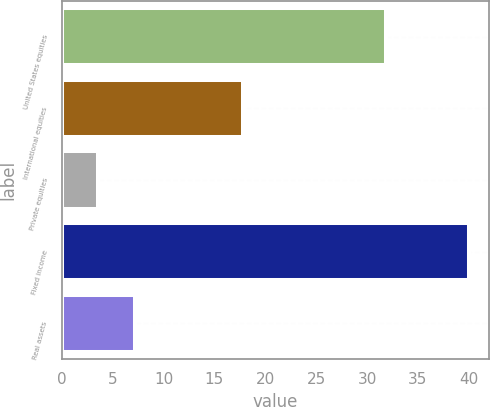Convert chart to OTSL. <chart><loc_0><loc_0><loc_500><loc_500><bar_chart><fcel>United States equities<fcel>International equities<fcel>Private equities<fcel>Fixed income<fcel>Real assets<nl><fcel>31.9<fcel>17.8<fcel>3.6<fcel>40<fcel>7.24<nl></chart> 